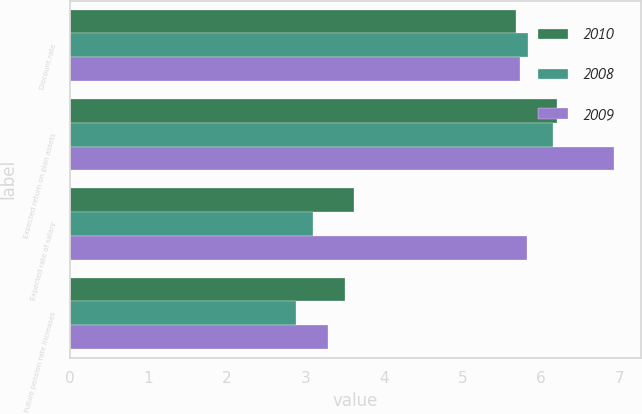<chart> <loc_0><loc_0><loc_500><loc_500><stacked_bar_chart><ecel><fcel>Discount rate<fcel>Expected return on plan assets<fcel>Expected rate of salary<fcel>Future pension rate increases<nl><fcel>2010<fcel>5.68<fcel>6.2<fcel>3.62<fcel>3.5<nl><fcel>2008<fcel>5.84<fcel>6.15<fcel>3.09<fcel>2.88<nl><fcel>2009<fcel>5.73<fcel>6.93<fcel>5.82<fcel>3.28<nl></chart> 